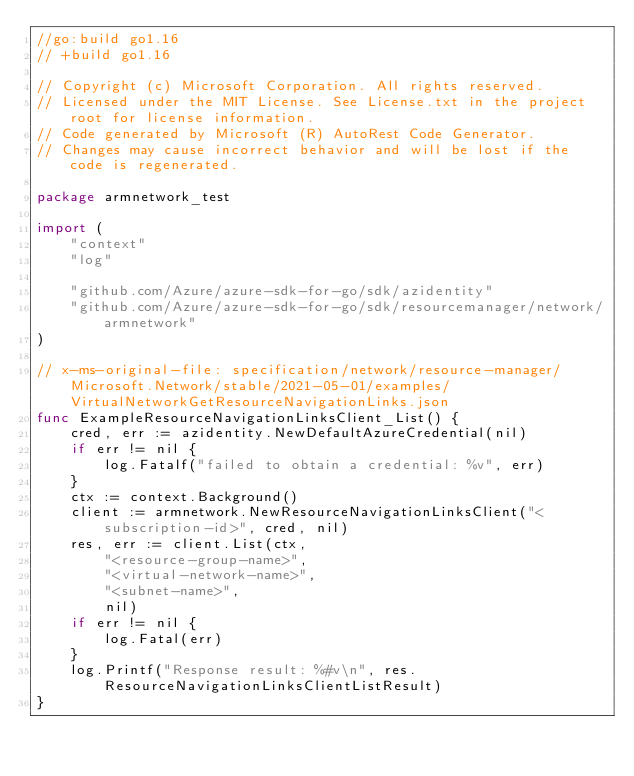Convert code to text. <code><loc_0><loc_0><loc_500><loc_500><_Go_>//go:build go1.16
// +build go1.16

// Copyright (c) Microsoft Corporation. All rights reserved.
// Licensed under the MIT License. See License.txt in the project root for license information.
// Code generated by Microsoft (R) AutoRest Code Generator.
// Changes may cause incorrect behavior and will be lost if the code is regenerated.

package armnetwork_test

import (
	"context"
	"log"

	"github.com/Azure/azure-sdk-for-go/sdk/azidentity"
	"github.com/Azure/azure-sdk-for-go/sdk/resourcemanager/network/armnetwork"
)

// x-ms-original-file: specification/network/resource-manager/Microsoft.Network/stable/2021-05-01/examples/VirtualNetworkGetResourceNavigationLinks.json
func ExampleResourceNavigationLinksClient_List() {
	cred, err := azidentity.NewDefaultAzureCredential(nil)
	if err != nil {
		log.Fatalf("failed to obtain a credential: %v", err)
	}
	ctx := context.Background()
	client := armnetwork.NewResourceNavigationLinksClient("<subscription-id>", cred, nil)
	res, err := client.List(ctx,
		"<resource-group-name>",
		"<virtual-network-name>",
		"<subnet-name>",
		nil)
	if err != nil {
		log.Fatal(err)
	}
	log.Printf("Response result: %#v\n", res.ResourceNavigationLinksClientListResult)
}
</code> 